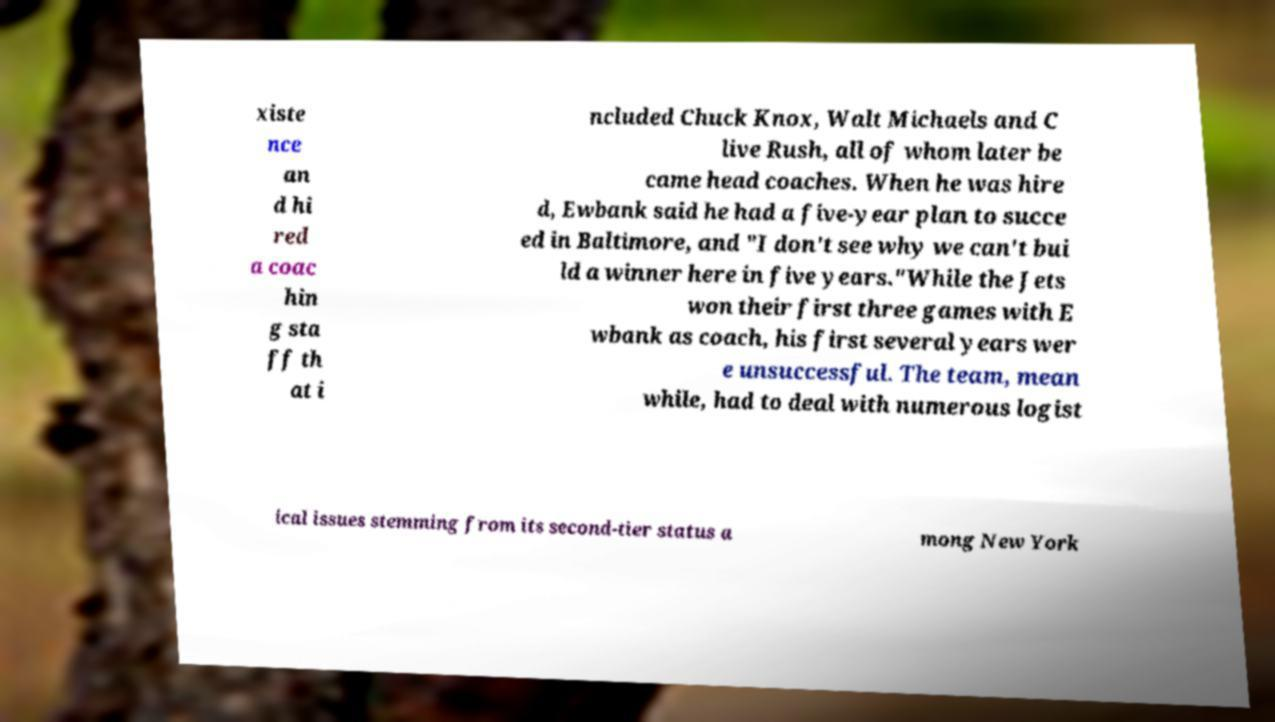What messages or text are displayed in this image? I need them in a readable, typed format. xiste nce an d hi red a coac hin g sta ff th at i ncluded Chuck Knox, Walt Michaels and C live Rush, all of whom later be came head coaches. When he was hire d, Ewbank said he had a five-year plan to succe ed in Baltimore, and "I don't see why we can't bui ld a winner here in five years."While the Jets won their first three games with E wbank as coach, his first several years wer e unsuccessful. The team, mean while, had to deal with numerous logist ical issues stemming from its second-tier status a mong New York 